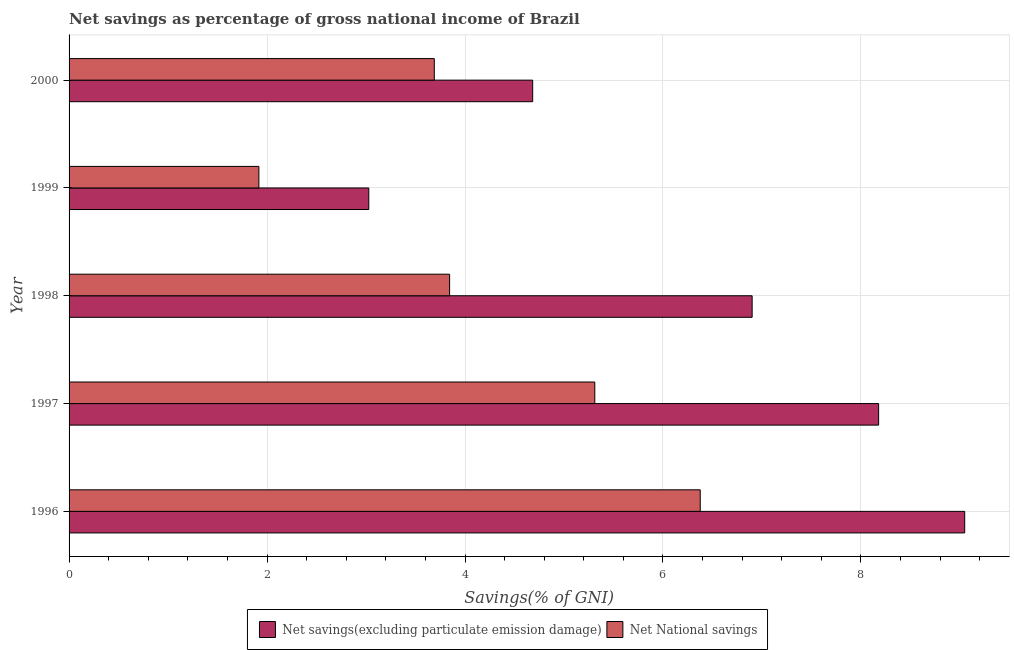How many different coloured bars are there?
Your answer should be compact. 2. Are the number of bars per tick equal to the number of legend labels?
Your response must be concise. Yes. Are the number of bars on each tick of the Y-axis equal?
Give a very brief answer. Yes. How many bars are there on the 5th tick from the bottom?
Your answer should be compact. 2. What is the net savings(excluding particulate emission damage) in 1997?
Offer a terse response. 8.18. Across all years, what is the maximum net national savings?
Make the answer very short. 6.38. Across all years, what is the minimum net national savings?
Your answer should be compact. 1.92. In which year was the net savings(excluding particulate emission damage) maximum?
Offer a very short reply. 1996. What is the total net savings(excluding particulate emission damage) in the graph?
Make the answer very short. 31.84. What is the difference between the net savings(excluding particulate emission damage) in 1998 and that in 2000?
Provide a short and direct response. 2.22. What is the difference between the net savings(excluding particulate emission damage) in 1998 and the net national savings in 1999?
Offer a very short reply. 4.98. What is the average net national savings per year?
Make the answer very short. 4.23. In the year 1997, what is the difference between the net national savings and net savings(excluding particulate emission damage)?
Your answer should be very brief. -2.87. What is the ratio of the net savings(excluding particulate emission damage) in 1997 to that in 1999?
Provide a succinct answer. 2.7. Is the net national savings in 1999 less than that in 2000?
Give a very brief answer. Yes. What is the difference between the highest and the second highest net national savings?
Your answer should be very brief. 1.06. What is the difference between the highest and the lowest net national savings?
Your answer should be very brief. 4.46. What does the 2nd bar from the top in 1997 represents?
Your answer should be compact. Net savings(excluding particulate emission damage). What does the 1st bar from the bottom in 1996 represents?
Your answer should be very brief. Net savings(excluding particulate emission damage). How many years are there in the graph?
Your answer should be very brief. 5. What is the difference between two consecutive major ticks on the X-axis?
Provide a short and direct response. 2. Does the graph contain any zero values?
Keep it short and to the point. No. How many legend labels are there?
Make the answer very short. 2. How are the legend labels stacked?
Make the answer very short. Horizontal. What is the title of the graph?
Keep it short and to the point. Net savings as percentage of gross national income of Brazil. Does "Primary" appear as one of the legend labels in the graph?
Offer a terse response. No. What is the label or title of the X-axis?
Offer a terse response. Savings(% of GNI). What is the Savings(% of GNI) of Net savings(excluding particulate emission damage) in 1996?
Give a very brief answer. 9.05. What is the Savings(% of GNI) in Net National savings in 1996?
Your response must be concise. 6.38. What is the Savings(% of GNI) in Net savings(excluding particulate emission damage) in 1997?
Your answer should be compact. 8.18. What is the Savings(% of GNI) in Net National savings in 1997?
Offer a very short reply. 5.31. What is the Savings(% of GNI) in Net savings(excluding particulate emission damage) in 1998?
Your answer should be compact. 6.9. What is the Savings(% of GNI) in Net National savings in 1998?
Provide a short and direct response. 3.84. What is the Savings(% of GNI) in Net savings(excluding particulate emission damage) in 1999?
Your answer should be compact. 3.03. What is the Savings(% of GNI) of Net National savings in 1999?
Make the answer very short. 1.92. What is the Savings(% of GNI) of Net savings(excluding particulate emission damage) in 2000?
Offer a very short reply. 4.68. What is the Savings(% of GNI) of Net National savings in 2000?
Offer a terse response. 3.69. Across all years, what is the maximum Savings(% of GNI) in Net savings(excluding particulate emission damage)?
Ensure brevity in your answer.  9.05. Across all years, what is the maximum Savings(% of GNI) in Net National savings?
Provide a succinct answer. 6.38. Across all years, what is the minimum Savings(% of GNI) of Net savings(excluding particulate emission damage)?
Offer a terse response. 3.03. Across all years, what is the minimum Savings(% of GNI) of Net National savings?
Your response must be concise. 1.92. What is the total Savings(% of GNI) of Net savings(excluding particulate emission damage) in the graph?
Your answer should be compact. 31.84. What is the total Savings(% of GNI) in Net National savings in the graph?
Make the answer very short. 21.14. What is the difference between the Savings(% of GNI) of Net savings(excluding particulate emission damage) in 1996 and that in 1997?
Offer a terse response. 0.87. What is the difference between the Savings(% of GNI) of Net National savings in 1996 and that in 1997?
Make the answer very short. 1.07. What is the difference between the Savings(% of GNI) in Net savings(excluding particulate emission damage) in 1996 and that in 1998?
Your answer should be compact. 2.15. What is the difference between the Savings(% of GNI) of Net National savings in 1996 and that in 1998?
Offer a terse response. 2.53. What is the difference between the Savings(% of GNI) of Net savings(excluding particulate emission damage) in 1996 and that in 1999?
Your answer should be compact. 6.02. What is the difference between the Savings(% of GNI) in Net National savings in 1996 and that in 1999?
Your answer should be compact. 4.46. What is the difference between the Savings(% of GNI) in Net savings(excluding particulate emission damage) in 1996 and that in 2000?
Ensure brevity in your answer.  4.36. What is the difference between the Savings(% of GNI) of Net National savings in 1996 and that in 2000?
Ensure brevity in your answer.  2.69. What is the difference between the Savings(% of GNI) in Net savings(excluding particulate emission damage) in 1997 and that in 1998?
Offer a very short reply. 1.28. What is the difference between the Savings(% of GNI) in Net National savings in 1997 and that in 1998?
Provide a short and direct response. 1.47. What is the difference between the Savings(% of GNI) in Net savings(excluding particulate emission damage) in 1997 and that in 1999?
Your answer should be compact. 5.15. What is the difference between the Savings(% of GNI) of Net National savings in 1997 and that in 1999?
Ensure brevity in your answer.  3.39. What is the difference between the Savings(% of GNI) of Net savings(excluding particulate emission damage) in 1997 and that in 2000?
Offer a very short reply. 3.49. What is the difference between the Savings(% of GNI) of Net National savings in 1997 and that in 2000?
Make the answer very short. 1.62. What is the difference between the Savings(% of GNI) of Net savings(excluding particulate emission damage) in 1998 and that in 1999?
Offer a very short reply. 3.87. What is the difference between the Savings(% of GNI) of Net National savings in 1998 and that in 1999?
Give a very brief answer. 1.93. What is the difference between the Savings(% of GNI) of Net savings(excluding particulate emission damage) in 1998 and that in 2000?
Your response must be concise. 2.22. What is the difference between the Savings(% of GNI) of Net National savings in 1998 and that in 2000?
Your answer should be very brief. 0.15. What is the difference between the Savings(% of GNI) of Net savings(excluding particulate emission damage) in 1999 and that in 2000?
Your answer should be very brief. -1.66. What is the difference between the Savings(% of GNI) in Net National savings in 1999 and that in 2000?
Keep it short and to the point. -1.77. What is the difference between the Savings(% of GNI) in Net savings(excluding particulate emission damage) in 1996 and the Savings(% of GNI) in Net National savings in 1997?
Give a very brief answer. 3.74. What is the difference between the Savings(% of GNI) of Net savings(excluding particulate emission damage) in 1996 and the Savings(% of GNI) of Net National savings in 1998?
Ensure brevity in your answer.  5.2. What is the difference between the Savings(% of GNI) of Net savings(excluding particulate emission damage) in 1996 and the Savings(% of GNI) of Net National savings in 1999?
Provide a short and direct response. 7.13. What is the difference between the Savings(% of GNI) in Net savings(excluding particulate emission damage) in 1996 and the Savings(% of GNI) in Net National savings in 2000?
Offer a terse response. 5.36. What is the difference between the Savings(% of GNI) in Net savings(excluding particulate emission damage) in 1997 and the Savings(% of GNI) in Net National savings in 1998?
Give a very brief answer. 4.33. What is the difference between the Savings(% of GNI) in Net savings(excluding particulate emission damage) in 1997 and the Savings(% of GNI) in Net National savings in 1999?
Provide a succinct answer. 6.26. What is the difference between the Savings(% of GNI) in Net savings(excluding particulate emission damage) in 1997 and the Savings(% of GNI) in Net National savings in 2000?
Offer a terse response. 4.49. What is the difference between the Savings(% of GNI) in Net savings(excluding particulate emission damage) in 1998 and the Savings(% of GNI) in Net National savings in 1999?
Keep it short and to the point. 4.98. What is the difference between the Savings(% of GNI) of Net savings(excluding particulate emission damage) in 1998 and the Savings(% of GNI) of Net National savings in 2000?
Offer a terse response. 3.21. What is the difference between the Savings(% of GNI) of Net savings(excluding particulate emission damage) in 1999 and the Savings(% of GNI) of Net National savings in 2000?
Your answer should be compact. -0.66. What is the average Savings(% of GNI) in Net savings(excluding particulate emission damage) per year?
Give a very brief answer. 6.37. What is the average Savings(% of GNI) in Net National savings per year?
Give a very brief answer. 4.23. In the year 1996, what is the difference between the Savings(% of GNI) of Net savings(excluding particulate emission damage) and Savings(% of GNI) of Net National savings?
Ensure brevity in your answer.  2.67. In the year 1997, what is the difference between the Savings(% of GNI) in Net savings(excluding particulate emission damage) and Savings(% of GNI) in Net National savings?
Provide a short and direct response. 2.87. In the year 1998, what is the difference between the Savings(% of GNI) of Net savings(excluding particulate emission damage) and Savings(% of GNI) of Net National savings?
Make the answer very short. 3.06. In the year 1999, what is the difference between the Savings(% of GNI) of Net savings(excluding particulate emission damage) and Savings(% of GNI) of Net National savings?
Provide a succinct answer. 1.11. What is the ratio of the Savings(% of GNI) in Net savings(excluding particulate emission damage) in 1996 to that in 1997?
Keep it short and to the point. 1.11. What is the ratio of the Savings(% of GNI) in Net National savings in 1996 to that in 1997?
Your answer should be compact. 1.2. What is the ratio of the Savings(% of GNI) of Net savings(excluding particulate emission damage) in 1996 to that in 1998?
Offer a terse response. 1.31. What is the ratio of the Savings(% of GNI) of Net National savings in 1996 to that in 1998?
Your answer should be very brief. 1.66. What is the ratio of the Savings(% of GNI) of Net savings(excluding particulate emission damage) in 1996 to that in 1999?
Your response must be concise. 2.99. What is the ratio of the Savings(% of GNI) of Net National savings in 1996 to that in 1999?
Provide a short and direct response. 3.33. What is the ratio of the Savings(% of GNI) of Net savings(excluding particulate emission damage) in 1996 to that in 2000?
Your answer should be very brief. 1.93. What is the ratio of the Savings(% of GNI) in Net National savings in 1996 to that in 2000?
Make the answer very short. 1.73. What is the ratio of the Savings(% of GNI) of Net savings(excluding particulate emission damage) in 1997 to that in 1998?
Offer a terse response. 1.19. What is the ratio of the Savings(% of GNI) in Net National savings in 1997 to that in 1998?
Provide a short and direct response. 1.38. What is the ratio of the Savings(% of GNI) in Net savings(excluding particulate emission damage) in 1997 to that in 1999?
Your response must be concise. 2.7. What is the ratio of the Savings(% of GNI) of Net National savings in 1997 to that in 1999?
Offer a terse response. 2.77. What is the ratio of the Savings(% of GNI) of Net savings(excluding particulate emission damage) in 1997 to that in 2000?
Offer a terse response. 1.75. What is the ratio of the Savings(% of GNI) of Net National savings in 1997 to that in 2000?
Keep it short and to the point. 1.44. What is the ratio of the Savings(% of GNI) of Net savings(excluding particulate emission damage) in 1998 to that in 1999?
Make the answer very short. 2.28. What is the ratio of the Savings(% of GNI) of Net National savings in 1998 to that in 1999?
Your answer should be compact. 2. What is the ratio of the Savings(% of GNI) in Net savings(excluding particulate emission damage) in 1998 to that in 2000?
Offer a terse response. 1.47. What is the ratio of the Savings(% of GNI) in Net National savings in 1998 to that in 2000?
Offer a very short reply. 1.04. What is the ratio of the Savings(% of GNI) in Net savings(excluding particulate emission damage) in 1999 to that in 2000?
Your response must be concise. 0.65. What is the ratio of the Savings(% of GNI) of Net National savings in 1999 to that in 2000?
Provide a succinct answer. 0.52. What is the difference between the highest and the second highest Savings(% of GNI) in Net savings(excluding particulate emission damage)?
Keep it short and to the point. 0.87. What is the difference between the highest and the second highest Savings(% of GNI) in Net National savings?
Give a very brief answer. 1.07. What is the difference between the highest and the lowest Savings(% of GNI) in Net savings(excluding particulate emission damage)?
Your answer should be compact. 6.02. What is the difference between the highest and the lowest Savings(% of GNI) in Net National savings?
Provide a short and direct response. 4.46. 